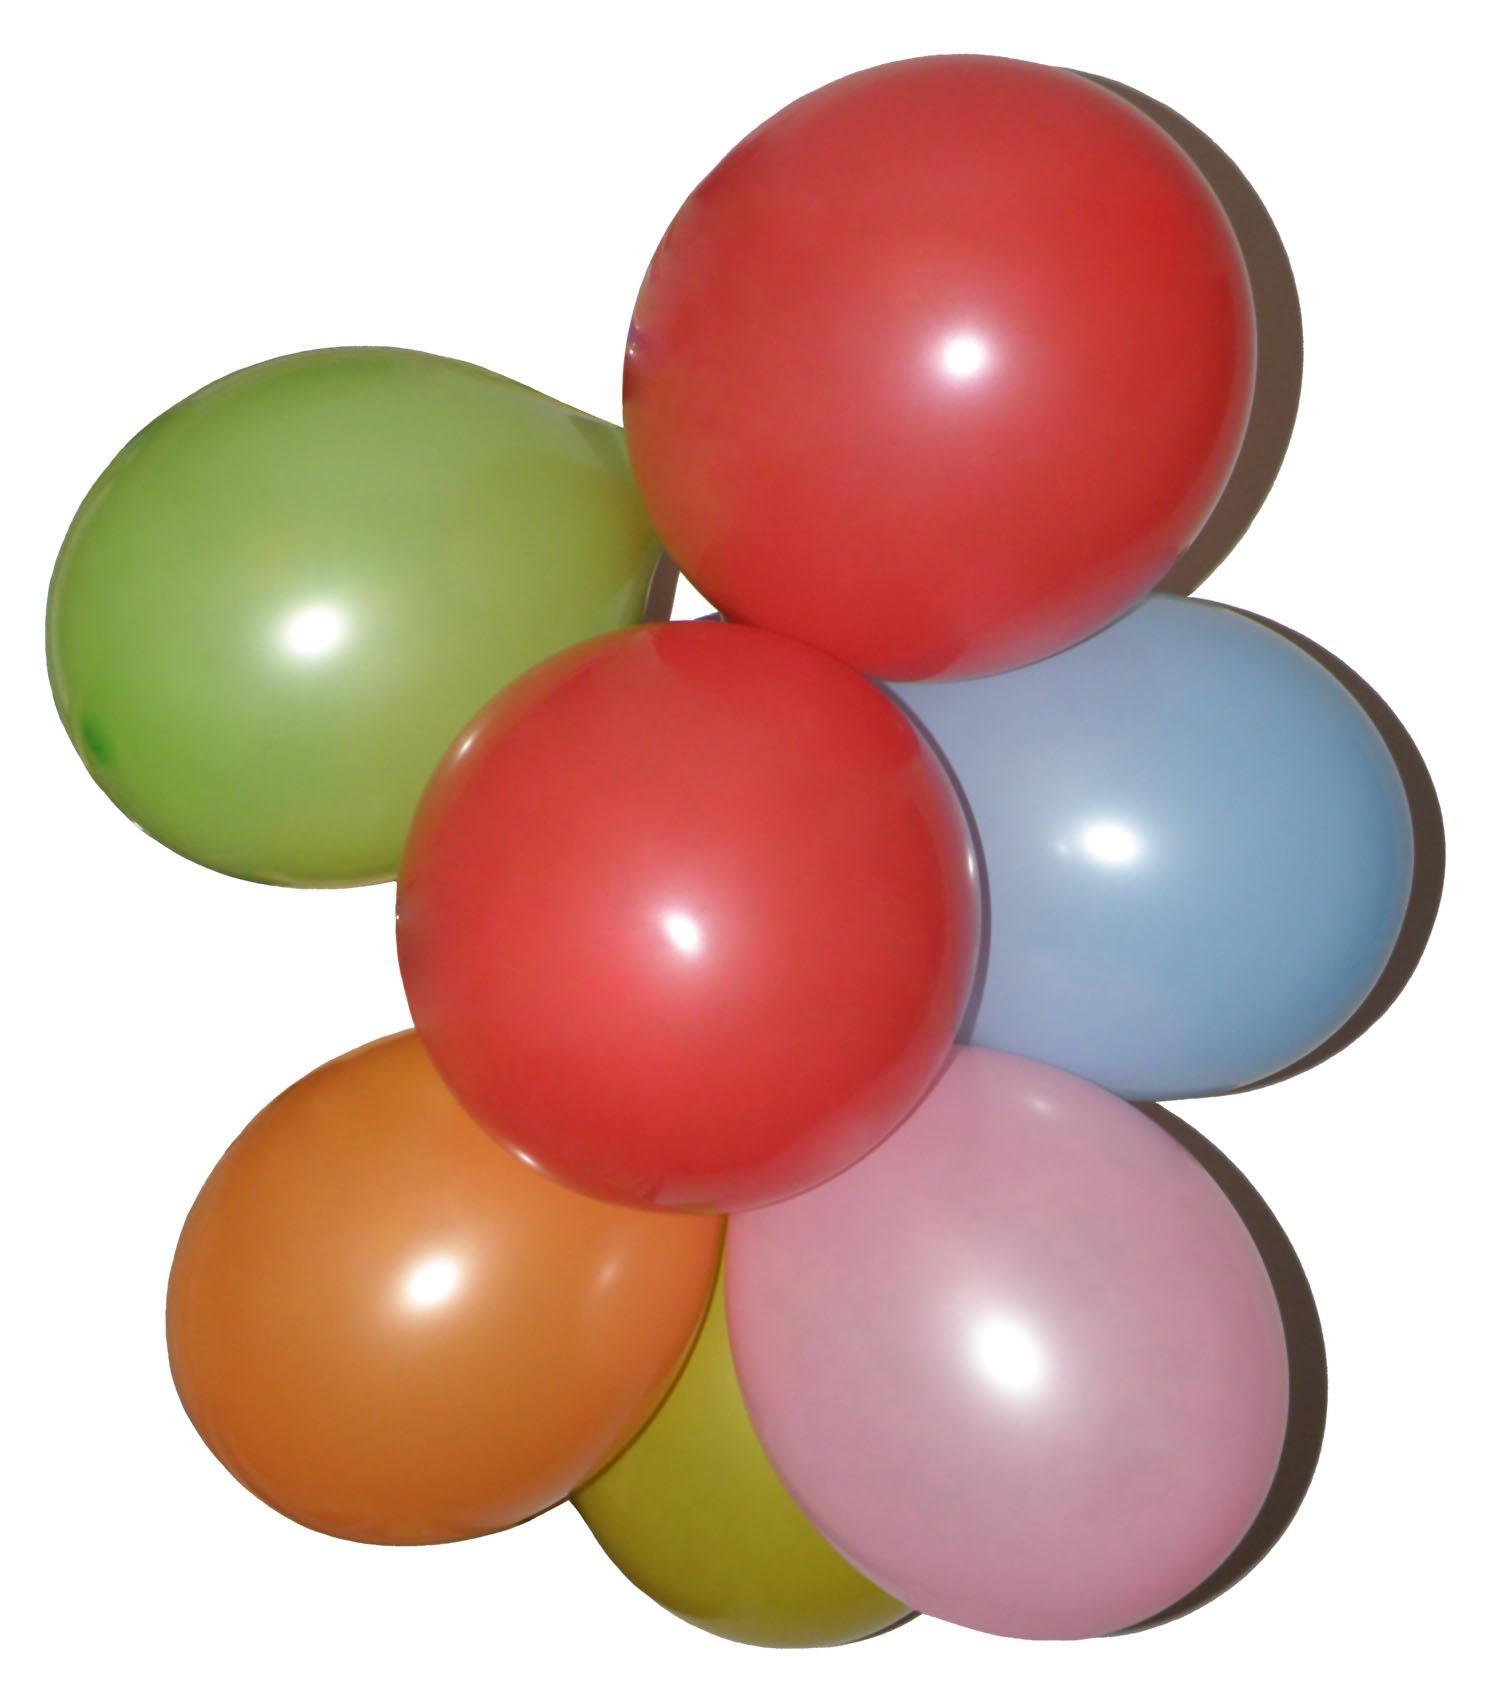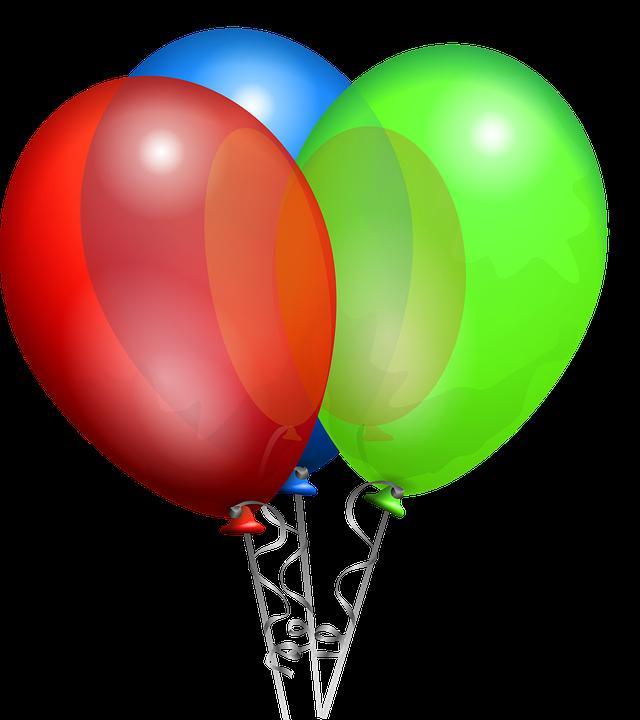The first image is the image on the left, the second image is the image on the right. Analyze the images presented: Is the assertion "The right image has three balloons all facing upwards." valid? Answer yes or no. Yes. 